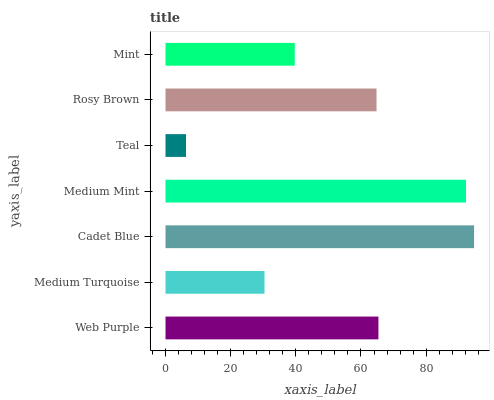Is Teal the minimum?
Answer yes or no. Yes. Is Cadet Blue the maximum?
Answer yes or no. Yes. Is Medium Turquoise the minimum?
Answer yes or no. No. Is Medium Turquoise the maximum?
Answer yes or no. No. Is Web Purple greater than Medium Turquoise?
Answer yes or no. Yes. Is Medium Turquoise less than Web Purple?
Answer yes or no. Yes. Is Medium Turquoise greater than Web Purple?
Answer yes or no. No. Is Web Purple less than Medium Turquoise?
Answer yes or no. No. Is Rosy Brown the high median?
Answer yes or no. Yes. Is Rosy Brown the low median?
Answer yes or no. Yes. Is Teal the high median?
Answer yes or no. No. Is Medium Mint the low median?
Answer yes or no. No. 